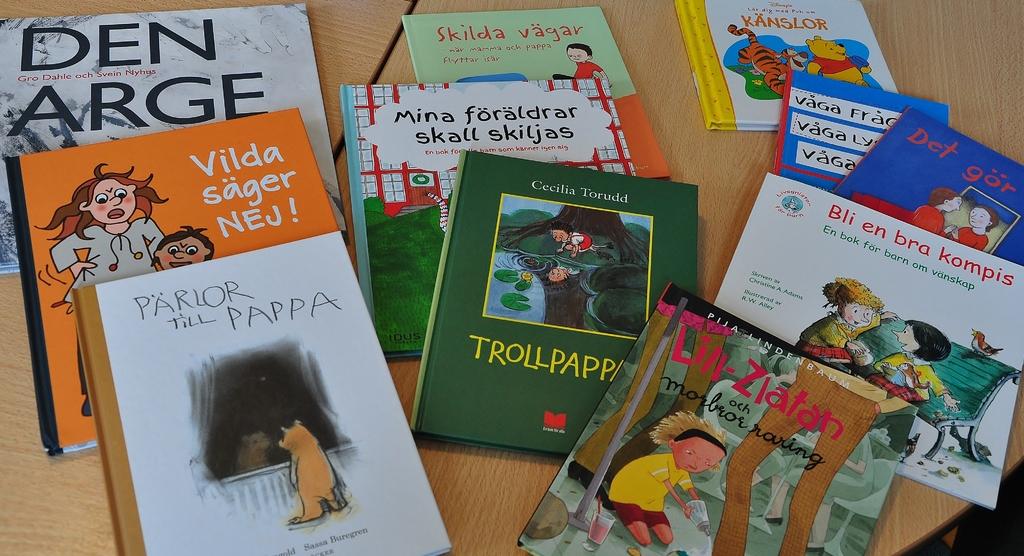What is the title of the book on the bottom left?
Your response must be concise. Parlor till pappa. What is the title of the orange book?
Provide a succinct answer. Vilda sager nej!. 